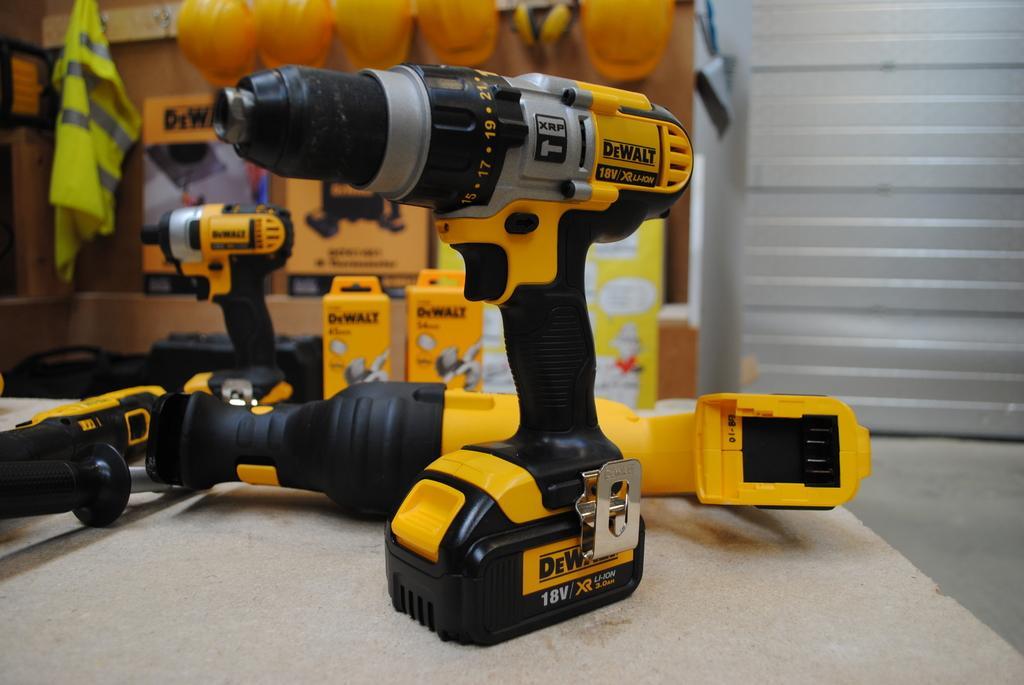Describe this image in one or two sentences. The picture consists of drilling machines. The background is blurred. In the background there are helmets, boxes and other objects. On the right there is a window blind. 